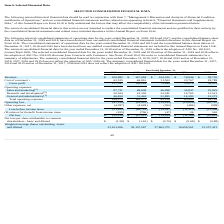From Everbridge's financial document, What was the revenue in 2019 and 2018? The document shows two values: 200,882 and 147,094 (in thousands). From the document: "Revenue $ 200,882 $ 147,094 $ 104,352 $ 76,846 $ 58,720 Revenue $ 200,882 $ 147,094 $ 104,352 $ 76,846 $ 58,720..." Also, What was the cost of revenue in 2019? According to the financial document, 63,535 (in thousands). The relevant text states: "Cost of revenue (1) 63,535 46,810 31,503 23,767 19,789..." Also, What was the Gross profit in 2018? According to the financial document, 100,284 (in thousands). The relevant text states: "Gross profit 137,347 100,284 72,849 53,079 38,931..." Additionally, In which year was revenue less than 100,000 thousands? The document shows two values: 2016 and 2015. Locate and analyze revenue in row 4. From the document: "2019 2018 2017 2016 2015 2019 2018 2017 2016 2015..." Also, can you calculate: What is the average cost of revenue from 2015-2019? To answer this question, I need to perform calculations using the financial data. The calculation is: (63,535 + 46,810 + 31,503 + 23,767 + 19,789) / 5, which equals 37080.8 (in thousands). This is based on the information: "Cost of revenue (1) 63,535 46,810 31,503 23,767 19,789 Cost of revenue (1) 63,535 46,810 31,503 23,767 19,789 Cost of revenue (1) 63,535 46,810 31,503 23,767 19,789 Cost of revenue (1) 63,535 46,810 3..." The key data points involved are: 19,789, 23,767, 31,503. Also, can you calculate: What is the change in the Gross Profit from 2018 to 2019? Based on the calculation: 137,347 - 100,284, the result is 37063 (in thousands). This is based on the information: "Gross profit 137,347 100,284 72,849 53,079 38,931 Gross profit 137,347 100,284 72,849 53,079 38,931..." The key data points involved are: 100,284, 137,347. 